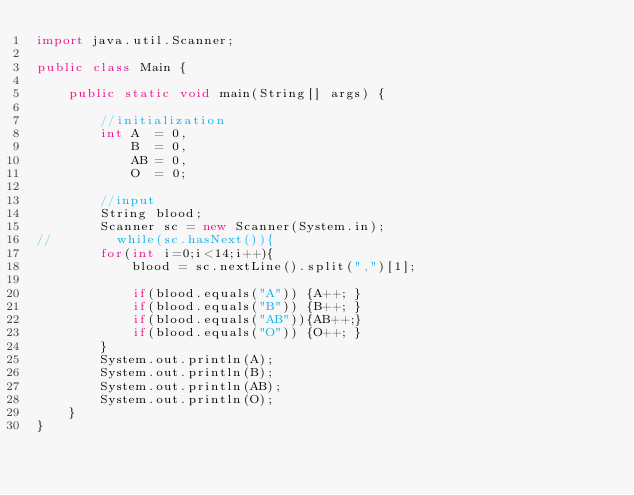Convert code to text. <code><loc_0><loc_0><loc_500><loc_500><_Java_>import java.util.Scanner;

public class Main {

	public static void main(String[] args) {

		//initialization
		int A  = 0,
            B  = 0,
            AB = 0,
            O  = 0;

        //input
		String blood;
        Scanner sc = new Scanner(System.in);
//        while(sc.hasNext()){
        for(int i=0;i<14;i++){
        	blood = sc.nextLine().split(",")[1];

        	if(blood.equals("A")) {A++; }
        	if(blood.equals("B")) {B++; }
        	if(blood.equals("AB")){AB++;}
        	if(blood.equals("O")) {O++; }
        }
        System.out.println(A);
        System.out.println(B);
        System.out.println(AB);
        System.out.println(O);
	}
}</code> 